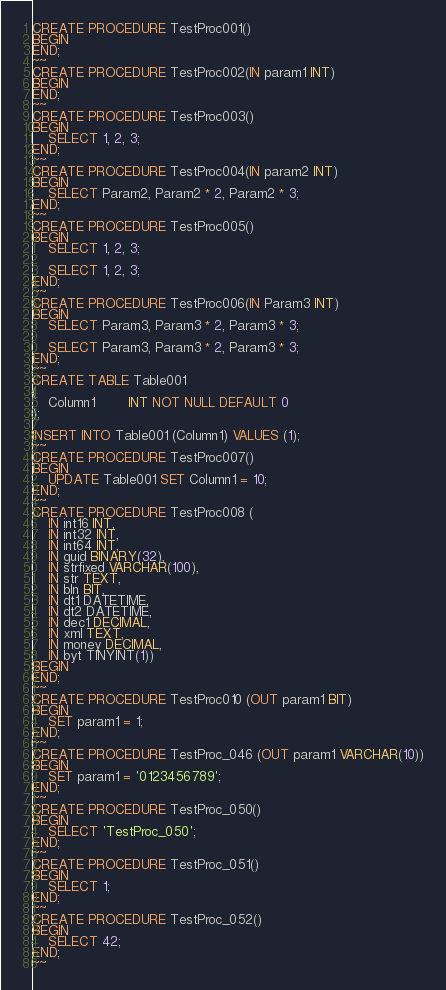<code> <loc_0><loc_0><loc_500><loc_500><_SQL_>CREATE PROCEDURE TestProc001()
BEGIN
END;
~~
CREATE PROCEDURE TestProc002(IN param1 INT)
BEGIN
END;
~~
CREATE PROCEDURE TestProc003()
BEGIN
	SELECT 1, 2, 3;
END;
~~
CREATE PROCEDURE TestProc004(IN param2 INT)
BEGIN	
	SELECT Param2, Param2 * 2, Param2 * 3;
END;
~~
CREATE PROCEDURE TestProc005()	
BEGIN
	SELECT 1, 2, 3;

	SELECT 1, 2, 3;
END;
~~
CREATE PROCEDURE TestProc006(IN Param3 INT)
BEGIN
	SELECT Param3, Param3 * 2, Param3 * 3;

	SELECT Param3, Param3 * 2, Param3 * 3;
END;
~~
CREATE TABLE Table001
(
	Column1		INT NOT NULL DEFAULT 0
);

INSERT INTO Table001 (Column1) VALUES (1);
~~
CREATE PROCEDURE TestProc007()
BEGIN
	UPDATE Table001 SET Column1 = 10;
END;
~~
CREATE PROCEDURE TestProc008 (
	IN int16 INT,
	IN int32 INT,
	IN int64 INT,
	IN guid BINARY(32),
	IN strfixed VARCHAR(100),
	IN str TEXT,
	IN bln BIT,
	IN dt1 DATETIME,
	IN dt2 DATETIME,
	IN dec1 DECIMAL,
	IN xml TEXT,
	IN money DECIMAL,
	IN byt TINYINT(1))
BEGIN
END;
~~
CREATE PROCEDURE TestProc010 (OUT param1 BIT)
BEGIN
	SET param1 = 1;
END;
~~
CREATE PROCEDURE TestProc_046 (OUT param1 VARCHAR(10))
BEGIN
	SET param1 = '0123456789';
END;
~~
CREATE PROCEDURE TestProc_050()
BEGIN
	SELECT 'TestProc_050';
END;
~~
CREATE PROCEDURE TestProc_051()
BEGIN
	SELECT 1;
END;
~~
CREATE PROCEDURE TestProc_052()
BEGIN
	SELECT 42;
END;
~~
</code> 